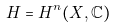Convert formula to latex. <formula><loc_0><loc_0><loc_500><loc_500>H = H ^ { n } ( X , \mathbb { C } )</formula> 